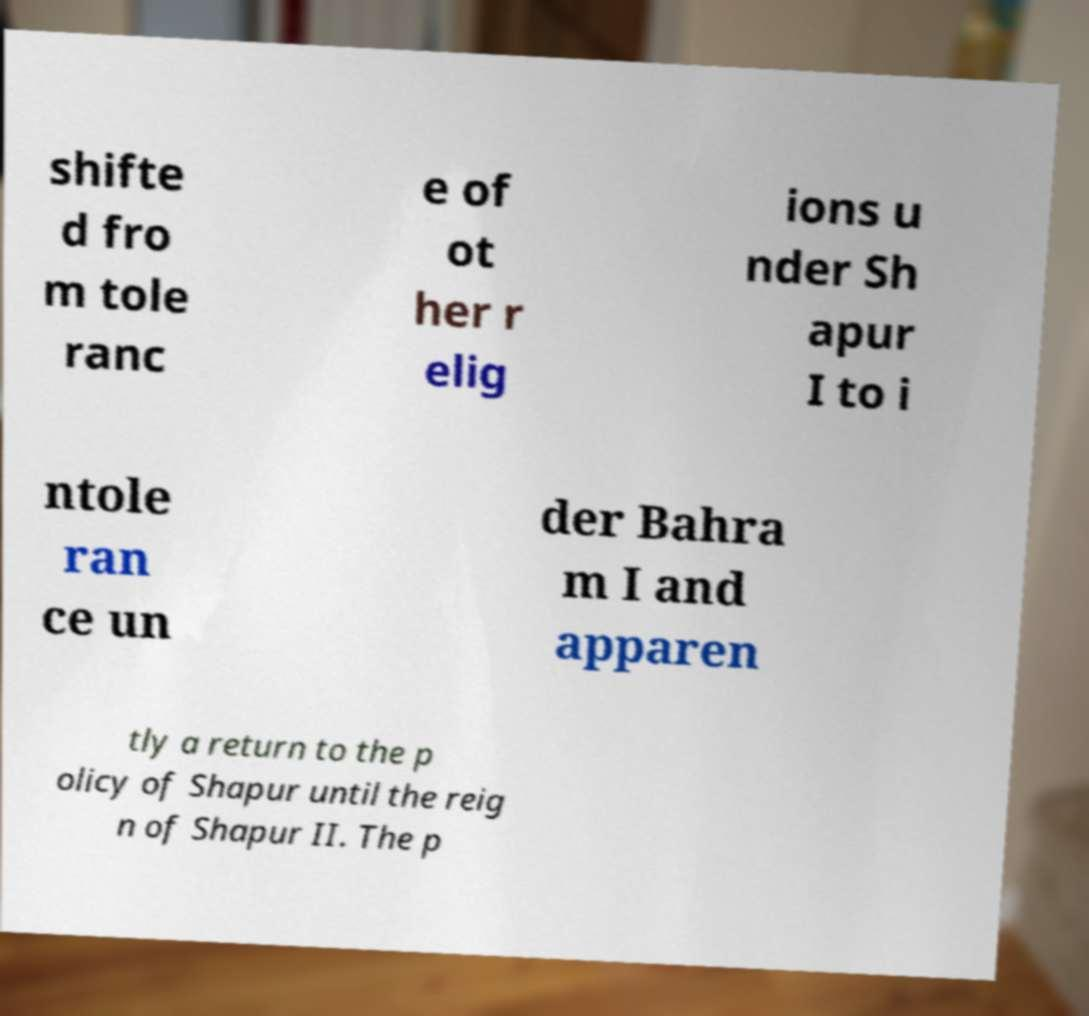Please identify and transcribe the text found in this image. shifte d fro m tole ranc e of ot her r elig ions u nder Sh apur I to i ntole ran ce un der Bahra m I and apparen tly a return to the p olicy of Shapur until the reig n of Shapur II. The p 